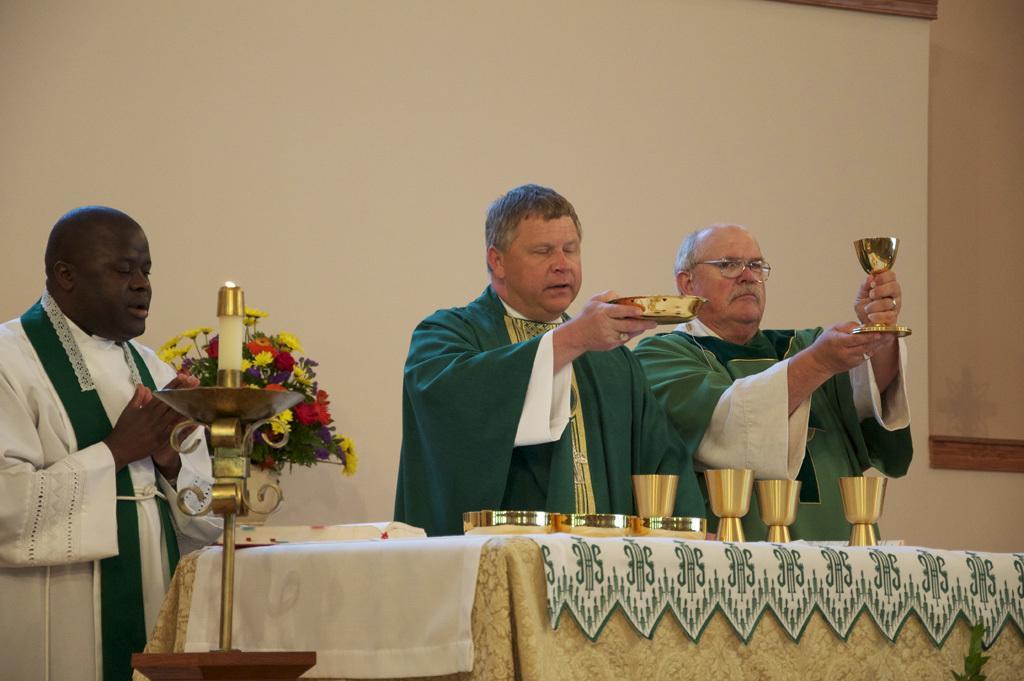How would you summarize this image in a sentence or two? In this picture we can see three men standing were two men holding a glass, bowl with their hands and in front of them we can see a candle stand, table with cloth, glasses, bowls and a book on the table, flower vase and in the background we can see the wall. 